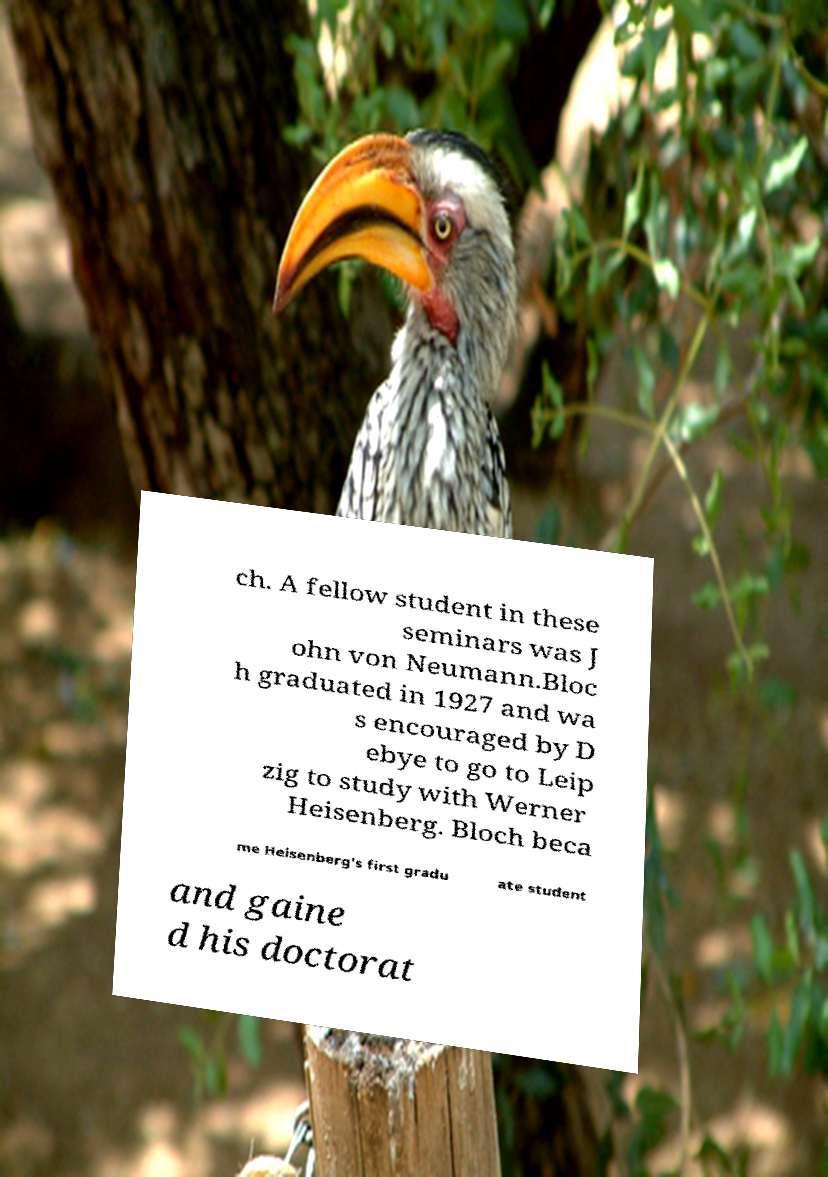Please identify and transcribe the text found in this image. ch. A fellow student in these seminars was J ohn von Neumann.Bloc h graduated in 1927 and wa s encouraged by D ebye to go to Leip zig to study with Werner Heisenberg. Bloch beca me Heisenberg's first gradu ate student and gaine d his doctorat 